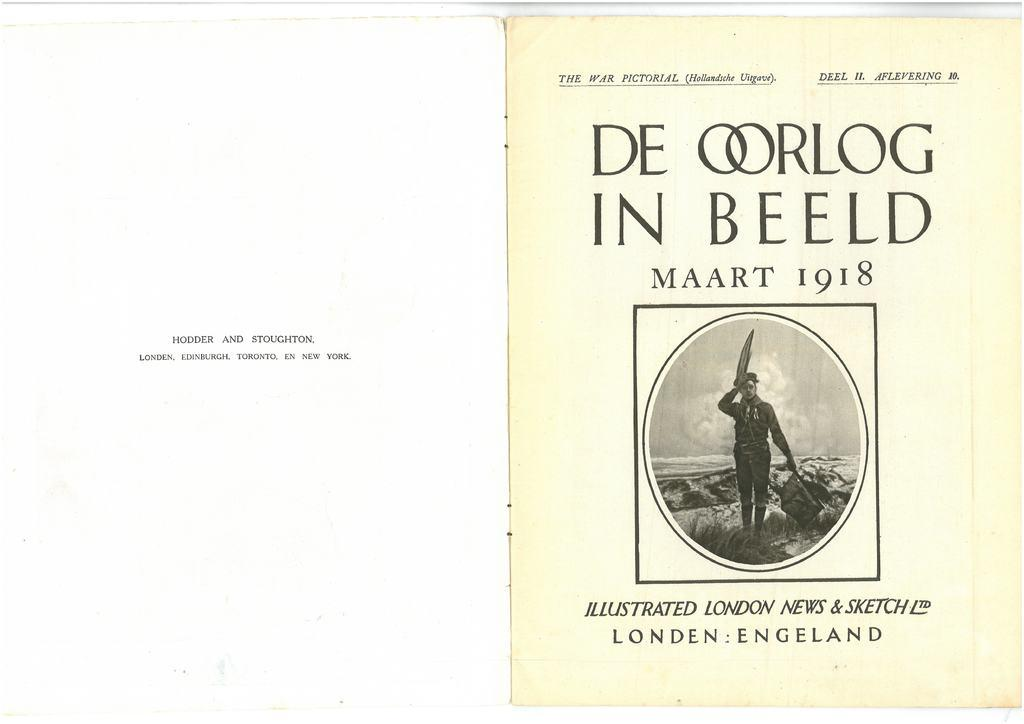<image>
Present a compact description of the photo's key features. A book is open showing the first page, indicating it was illustrated by London News and Sketch. 